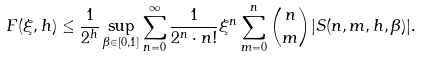<formula> <loc_0><loc_0><loc_500><loc_500>F ( \xi , h ) \leq \frac { 1 } { 2 ^ { h } } \sup _ { \beta \in [ 0 , 1 ] } \sum _ { n = 0 } ^ { \infty } \frac { 1 } { 2 ^ { n } \cdot n ! } \xi ^ { n } \sum _ { m = 0 } ^ { n } { n \choose m } | S ( n , m , h , \beta ) | .</formula> 